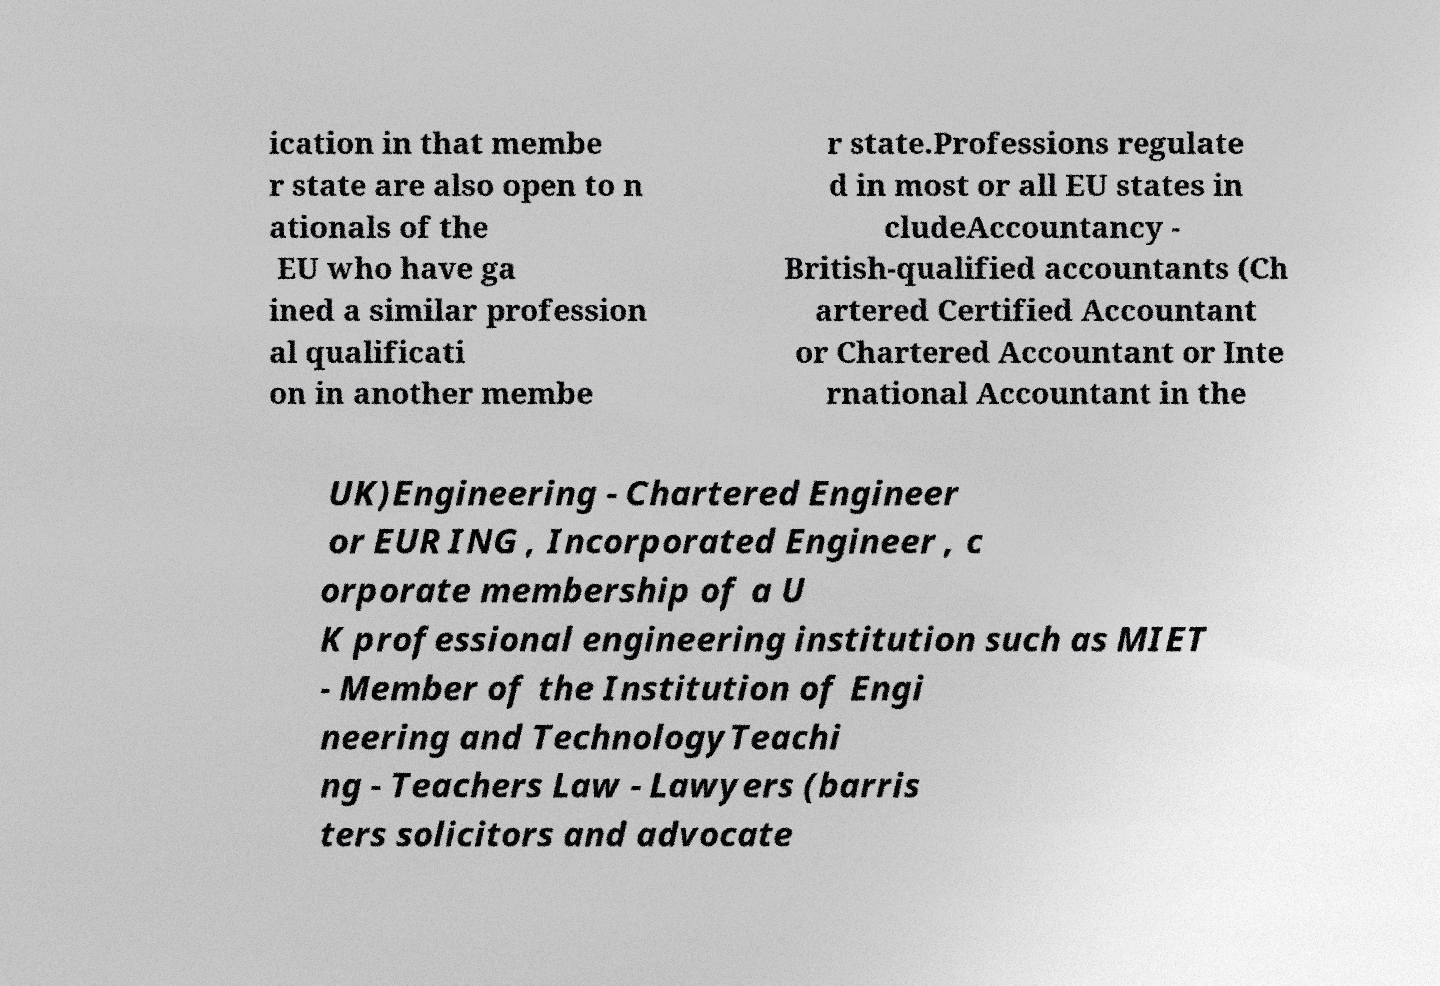Can you read and provide the text displayed in the image?This photo seems to have some interesting text. Can you extract and type it out for me? ication in that membe r state are also open to n ationals of the EU who have ga ined a similar profession al qualificati on in another membe r state.Professions regulate d in most or all EU states in cludeAccountancy - British-qualified accountants (Ch artered Certified Accountant or Chartered Accountant or Inte rnational Accountant in the UK)Engineering - Chartered Engineer or EUR ING , Incorporated Engineer , c orporate membership of a U K professional engineering institution such as MIET - Member of the Institution of Engi neering and TechnologyTeachi ng - Teachers Law - Lawyers (barris ters solicitors and advocate 